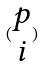<formula> <loc_0><loc_0><loc_500><loc_500>( \begin{matrix} p \\ i \end{matrix} )</formula> 